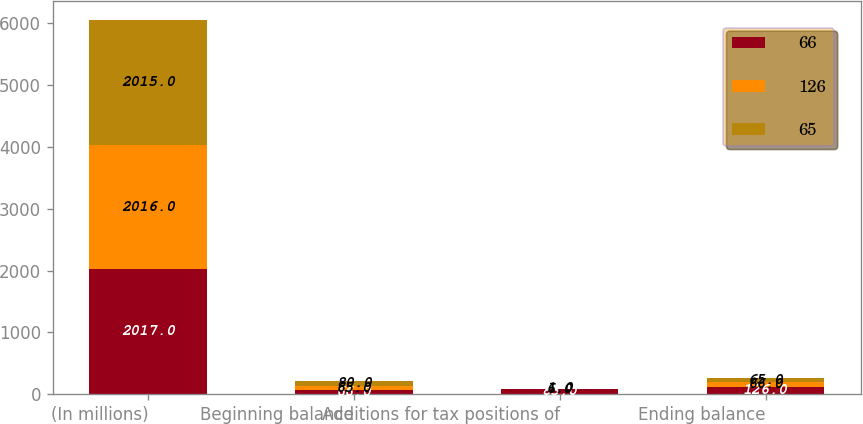Convert chart. <chart><loc_0><loc_0><loc_500><loc_500><stacked_bar_chart><ecel><fcel>(In millions)<fcel>Beginning balance<fcel>Additions for tax positions of<fcel>Ending balance<nl><fcel>66<fcel>2017<fcel>66<fcel>83<fcel>126<nl><fcel>126<fcel>2016<fcel>65<fcel>6<fcel>66<nl><fcel>65<fcel>2015<fcel>80<fcel>1<fcel>65<nl></chart> 